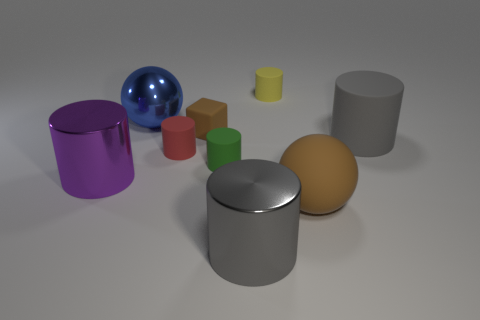Subtract 1 cylinders. How many cylinders are left? 5 Subtract all large metallic cylinders. How many cylinders are left? 4 Subtract all yellow cylinders. How many cylinders are left? 5 Subtract all blue cylinders. Subtract all green balls. How many cylinders are left? 6 Subtract all spheres. How many objects are left? 7 Add 8 large rubber cubes. How many large rubber cubes exist? 8 Subtract 0 cyan spheres. How many objects are left? 9 Subtract all gray rubber cylinders. Subtract all large purple cylinders. How many objects are left? 7 Add 1 red matte things. How many red matte things are left? 2 